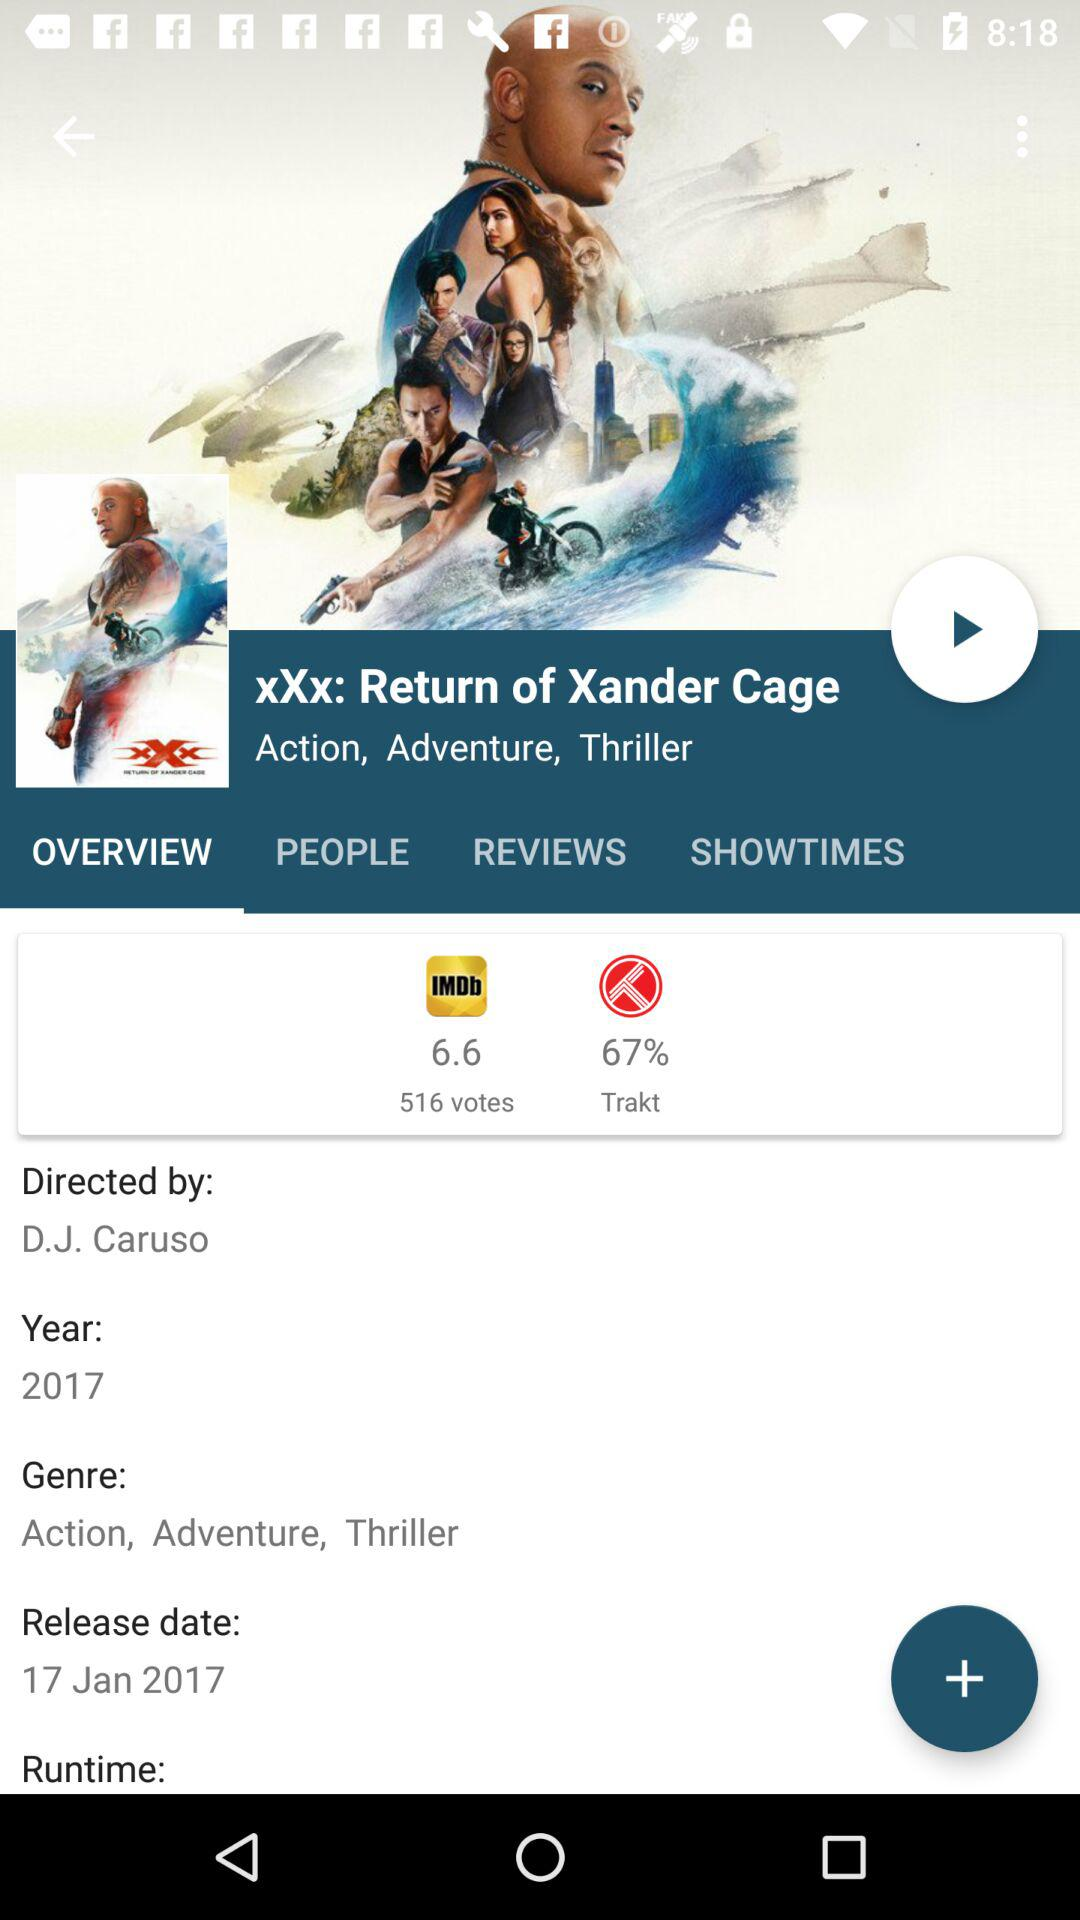How many votes did the movie get? The movie got 516 votes. 